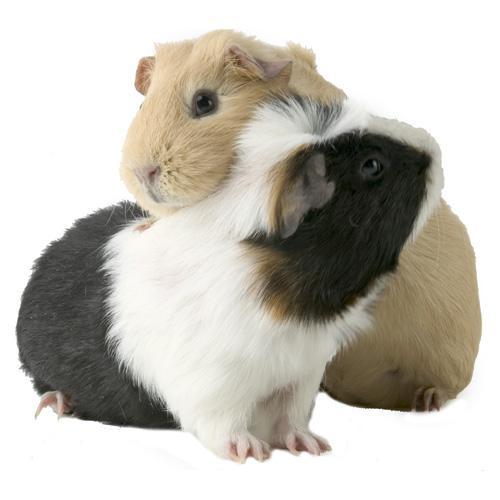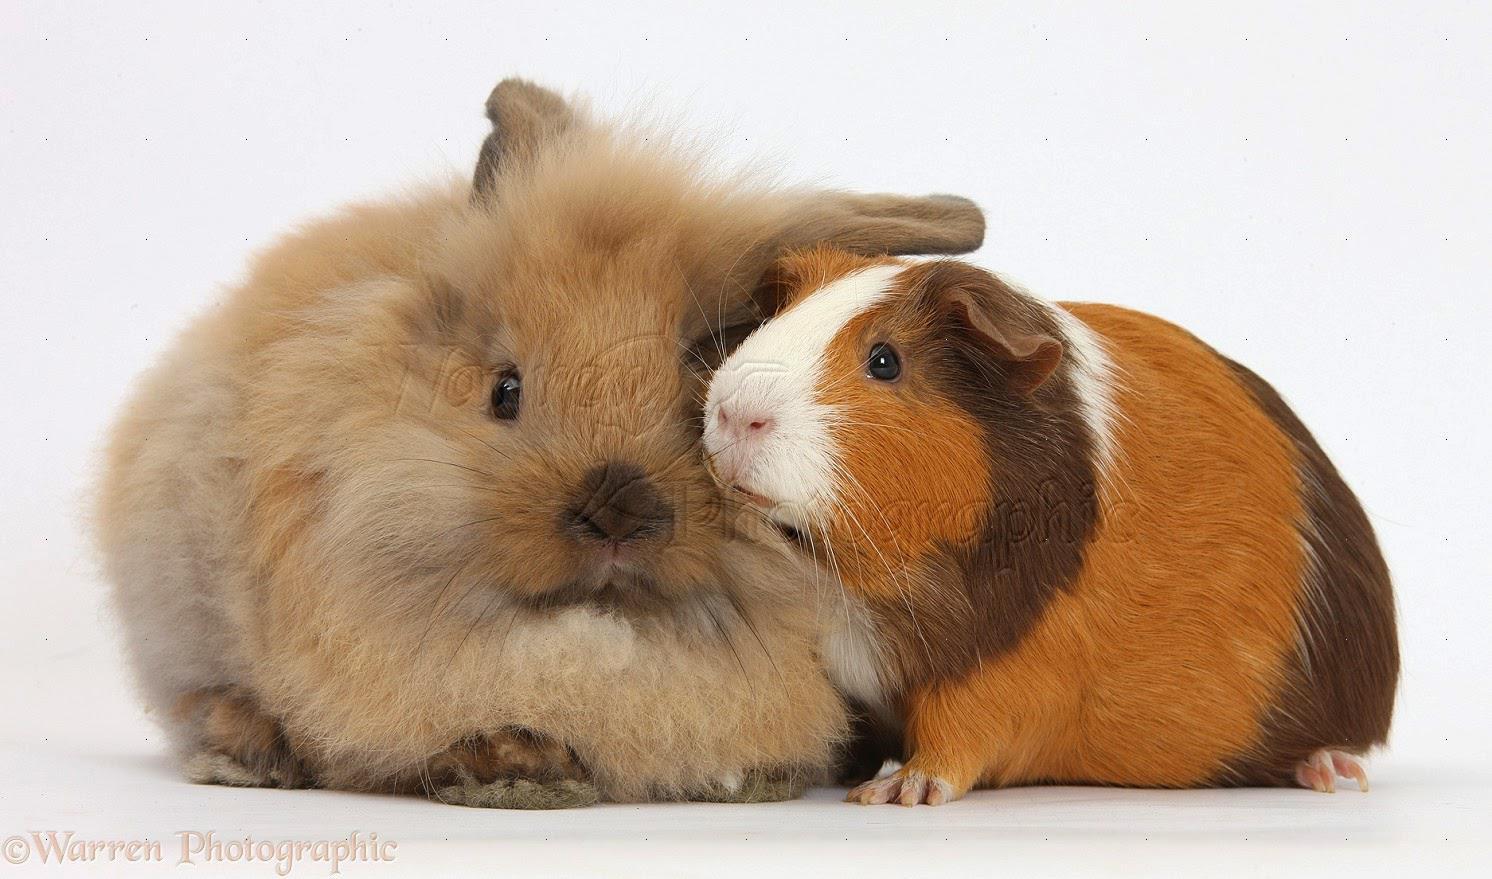The first image is the image on the left, the second image is the image on the right. For the images shown, is this caption "A rabbit is posing with the rodent in one of the images." true? Answer yes or no. Yes. The first image is the image on the left, the second image is the image on the right. Evaluate the accuracy of this statement regarding the images: "One image shows a multicolored guinea pig next to a different pet with longer ears.". Is it true? Answer yes or no. Yes. 